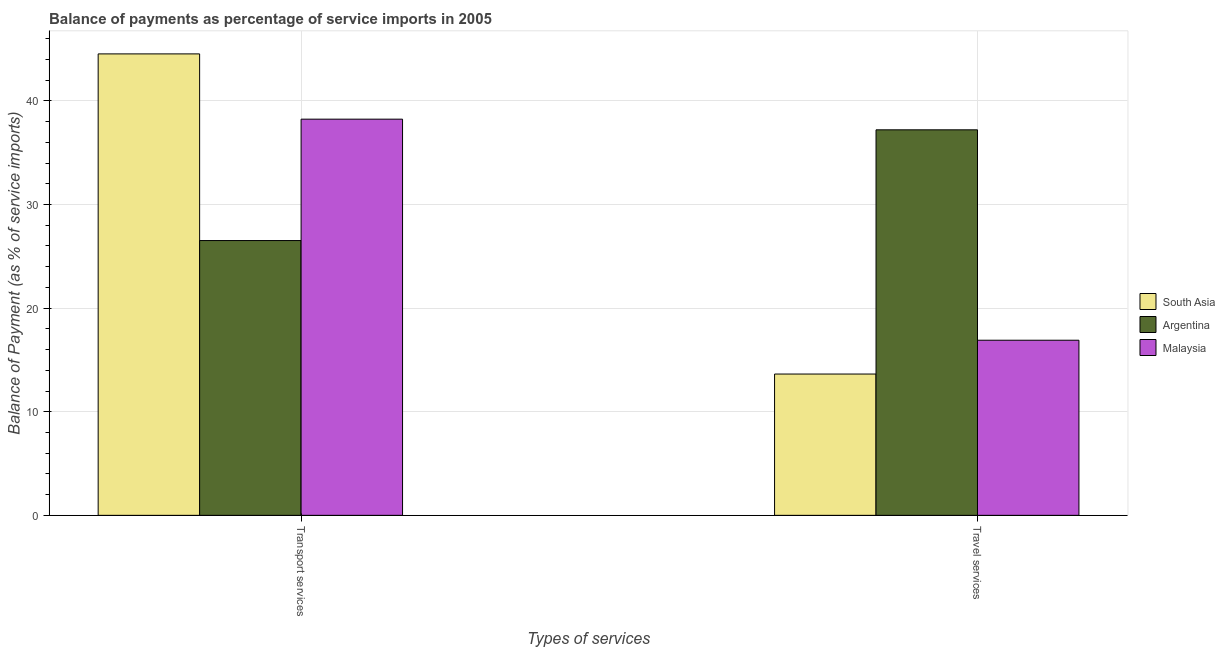How many different coloured bars are there?
Make the answer very short. 3. Are the number of bars per tick equal to the number of legend labels?
Make the answer very short. Yes. Are the number of bars on each tick of the X-axis equal?
Give a very brief answer. Yes. How many bars are there on the 1st tick from the left?
Keep it short and to the point. 3. How many bars are there on the 1st tick from the right?
Your answer should be compact. 3. What is the label of the 2nd group of bars from the left?
Ensure brevity in your answer.  Travel services. What is the balance of payments of transport services in South Asia?
Provide a succinct answer. 44.54. Across all countries, what is the maximum balance of payments of travel services?
Keep it short and to the point. 37.21. Across all countries, what is the minimum balance of payments of travel services?
Keep it short and to the point. 13.64. In which country was the balance of payments of transport services minimum?
Your answer should be compact. Argentina. What is the total balance of payments of transport services in the graph?
Give a very brief answer. 109.3. What is the difference between the balance of payments of travel services in South Asia and that in Malaysia?
Your answer should be very brief. -3.26. What is the difference between the balance of payments of travel services in Malaysia and the balance of payments of transport services in South Asia?
Give a very brief answer. -27.64. What is the average balance of payments of travel services per country?
Your answer should be compact. 22.58. What is the difference between the balance of payments of transport services and balance of payments of travel services in South Asia?
Offer a very short reply. 30.9. What is the ratio of the balance of payments of transport services in Argentina to that in Malaysia?
Give a very brief answer. 0.69. Is the balance of payments of travel services in South Asia less than that in Malaysia?
Keep it short and to the point. Yes. What does the 1st bar from the left in Transport services represents?
Your answer should be very brief. South Asia. What does the 2nd bar from the right in Travel services represents?
Offer a terse response. Argentina. How many bars are there?
Ensure brevity in your answer.  6. How many countries are there in the graph?
Your answer should be very brief. 3. What is the difference between two consecutive major ticks on the Y-axis?
Provide a succinct answer. 10. Does the graph contain grids?
Provide a short and direct response. Yes. Where does the legend appear in the graph?
Keep it short and to the point. Center right. What is the title of the graph?
Make the answer very short. Balance of payments as percentage of service imports in 2005. Does "Samoa" appear as one of the legend labels in the graph?
Your answer should be compact. No. What is the label or title of the X-axis?
Your response must be concise. Types of services. What is the label or title of the Y-axis?
Your answer should be very brief. Balance of Payment (as % of service imports). What is the Balance of Payment (as % of service imports) in South Asia in Transport services?
Offer a terse response. 44.54. What is the Balance of Payment (as % of service imports) of Argentina in Transport services?
Your response must be concise. 26.52. What is the Balance of Payment (as % of service imports) of Malaysia in Transport services?
Your answer should be compact. 38.24. What is the Balance of Payment (as % of service imports) in South Asia in Travel services?
Offer a very short reply. 13.64. What is the Balance of Payment (as % of service imports) of Argentina in Travel services?
Your response must be concise. 37.21. What is the Balance of Payment (as % of service imports) in Malaysia in Travel services?
Make the answer very short. 16.9. Across all Types of services, what is the maximum Balance of Payment (as % of service imports) in South Asia?
Make the answer very short. 44.54. Across all Types of services, what is the maximum Balance of Payment (as % of service imports) of Argentina?
Keep it short and to the point. 37.21. Across all Types of services, what is the maximum Balance of Payment (as % of service imports) in Malaysia?
Give a very brief answer. 38.24. Across all Types of services, what is the minimum Balance of Payment (as % of service imports) in South Asia?
Offer a terse response. 13.64. Across all Types of services, what is the minimum Balance of Payment (as % of service imports) in Argentina?
Offer a very short reply. 26.52. Across all Types of services, what is the minimum Balance of Payment (as % of service imports) of Malaysia?
Provide a short and direct response. 16.9. What is the total Balance of Payment (as % of service imports) of South Asia in the graph?
Keep it short and to the point. 58.18. What is the total Balance of Payment (as % of service imports) in Argentina in the graph?
Keep it short and to the point. 63.73. What is the total Balance of Payment (as % of service imports) in Malaysia in the graph?
Offer a terse response. 55.14. What is the difference between the Balance of Payment (as % of service imports) in South Asia in Transport services and that in Travel services?
Offer a very short reply. 30.9. What is the difference between the Balance of Payment (as % of service imports) of Argentina in Transport services and that in Travel services?
Provide a succinct answer. -10.69. What is the difference between the Balance of Payment (as % of service imports) of Malaysia in Transport services and that in Travel services?
Your answer should be very brief. 21.34. What is the difference between the Balance of Payment (as % of service imports) in South Asia in Transport services and the Balance of Payment (as % of service imports) in Argentina in Travel services?
Keep it short and to the point. 7.33. What is the difference between the Balance of Payment (as % of service imports) in South Asia in Transport services and the Balance of Payment (as % of service imports) in Malaysia in Travel services?
Your answer should be very brief. 27.64. What is the difference between the Balance of Payment (as % of service imports) in Argentina in Transport services and the Balance of Payment (as % of service imports) in Malaysia in Travel services?
Give a very brief answer. 9.62. What is the average Balance of Payment (as % of service imports) in South Asia per Types of services?
Offer a terse response. 29.09. What is the average Balance of Payment (as % of service imports) in Argentina per Types of services?
Ensure brevity in your answer.  31.87. What is the average Balance of Payment (as % of service imports) of Malaysia per Types of services?
Keep it short and to the point. 27.57. What is the difference between the Balance of Payment (as % of service imports) of South Asia and Balance of Payment (as % of service imports) of Argentina in Transport services?
Give a very brief answer. 18.02. What is the difference between the Balance of Payment (as % of service imports) of South Asia and Balance of Payment (as % of service imports) of Malaysia in Transport services?
Offer a very short reply. 6.3. What is the difference between the Balance of Payment (as % of service imports) in Argentina and Balance of Payment (as % of service imports) in Malaysia in Transport services?
Your answer should be very brief. -11.72. What is the difference between the Balance of Payment (as % of service imports) in South Asia and Balance of Payment (as % of service imports) in Argentina in Travel services?
Your response must be concise. -23.57. What is the difference between the Balance of Payment (as % of service imports) in South Asia and Balance of Payment (as % of service imports) in Malaysia in Travel services?
Offer a terse response. -3.26. What is the difference between the Balance of Payment (as % of service imports) of Argentina and Balance of Payment (as % of service imports) of Malaysia in Travel services?
Your response must be concise. 20.31. What is the ratio of the Balance of Payment (as % of service imports) of South Asia in Transport services to that in Travel services?
Provide a succinct answer. 3.27. What is the ratio of the Balance of Payment (as % of service imports) of Argentina in Transport services to that in Travel services?
Make the answer very short. 0.71. What is the ratio of the Balance of Payment (as % of service imports) of Malaysia in Transport services to that in Travel services?
Make the answer very short. 2.26. What is the difference between the highest and the second highest Balance of Payment (as % of service imports) of South Asia?
Provide a short and direct response. 30.9. What is the difference between the highest and the second highest Balance of Payment (as % of service imports) in Argentina?
Give a very brief answer. 10.69. What is the difference between the highest and the second highest Balance of Payment (as % of service imports) of Malaysia?
Provide a succinct answer. 21.34. What is the difference between the highest and the lowest Balance of Payment (as % of service imports) in South Asia?
Keep it short and to the point. 30.9. What is the difference between the highest and the lowest Balance of Payment (as % of service imports) in Argentina?
Your response must be concise. 10.69. What is the difference between the highest and the lowest Balance of Payment (as % of service imports) in Malaysia?
Keep it short and to the point. 21.34. 